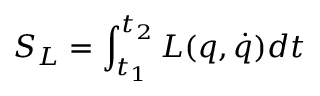<formula> <loc_0><loc_0><loc_500><loc_500>S _ { L } = \int _ { t _ { 1 } } ^ { t _ { 2 } } L ( q , \dot { q } ) d t</formula> 